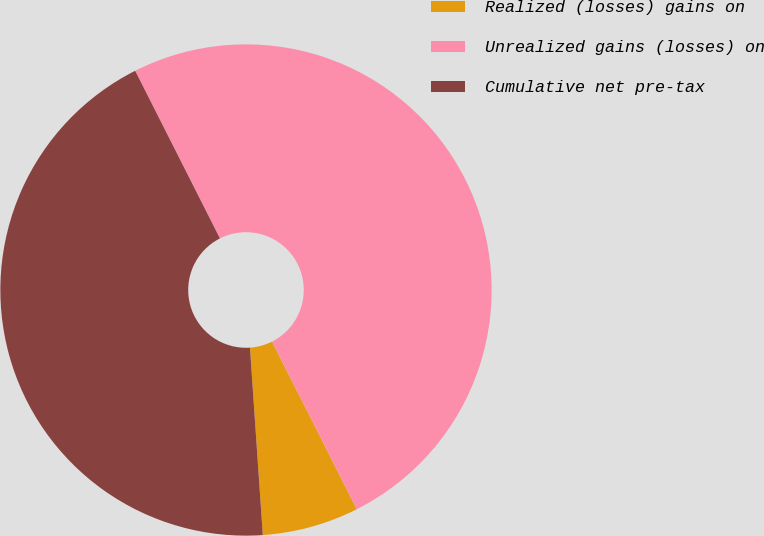<chart> <loc_0><loc_0><loc_500><loc_500><pie_chart><fcel>Realized (losses) gains on<fcel>Unrealized gains (losses) on<fcel>Cumulative net pre-tax<nl><fcel>6.36%<fcel>50.0%<fcel>43.64%<nl></chart> 